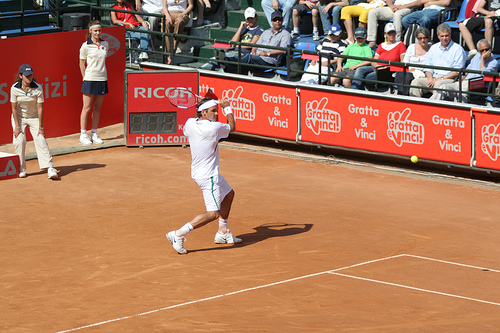Read all the text in this image. Gratta Vinci Gratta Vinci Gratta Vinci Gratta V Gra Vinci Vinci & Gratta Gratta & Vinci richo.com RICOH 